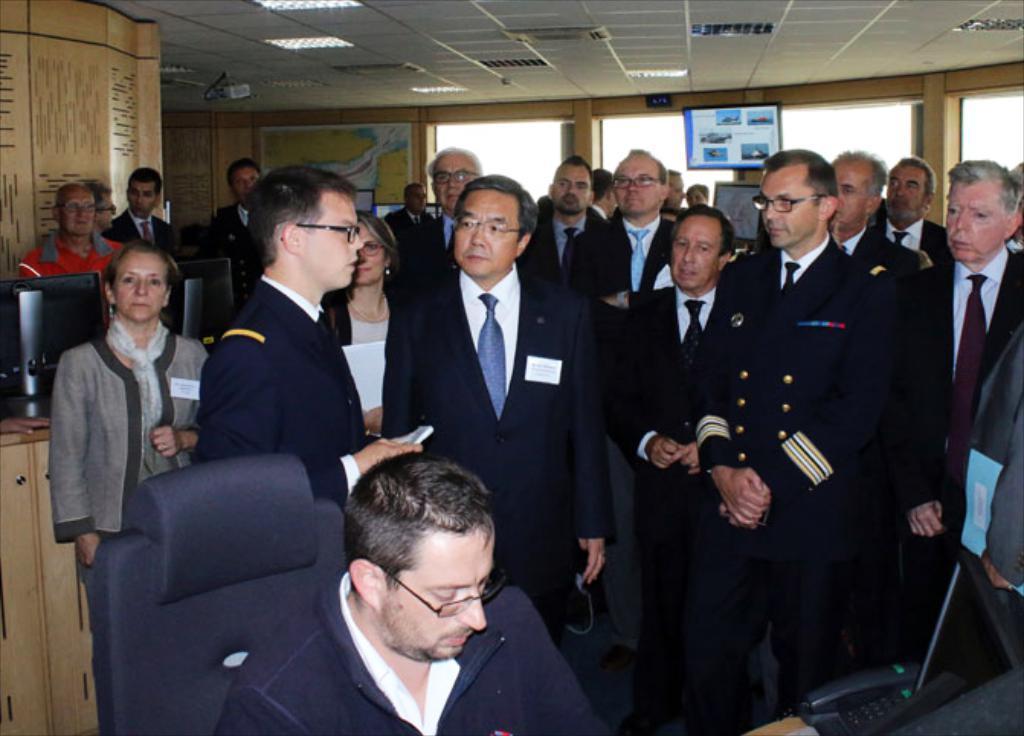Could you give a brief overview of what you see in this image? This is an inside view of a room. At the bottom of the image I can see a man is sitting on the chair. In front of him there is a table on which a telephone is placed. At the back of this person many people are standing and looking at one person who is standing on the left side. In the background, I can see a wall and windows. There is a screen is attached to the wall. On the top I can see the lights. 